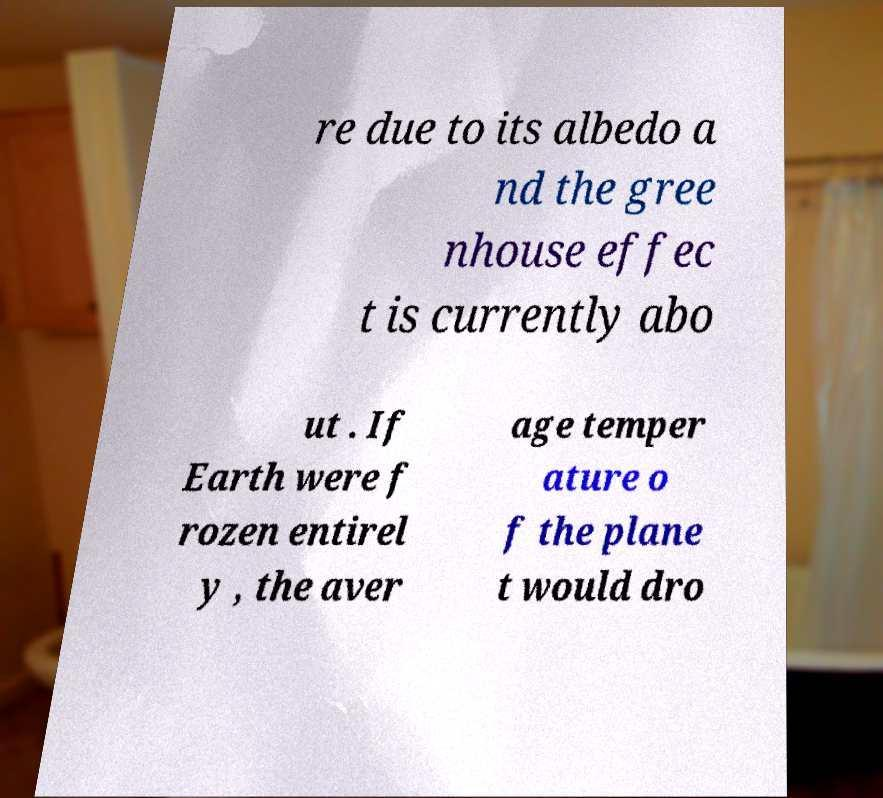Please read and relay the text visible in this image. What does it say? re due to its albedo a nd the gree nhouse effec t is currently abo ut . If Earth were f rozen entirel y , the aver age temper ature o f the plane t would dro 